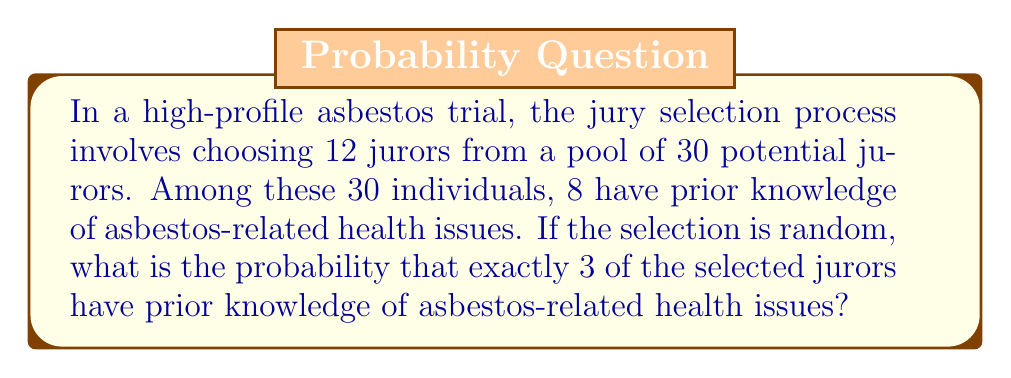Show me your answer to this math problem. Let's approach this step-by-step using the hypergeometric distribution:

1) We have:
   - Total population (N) = 30
   - Number of successes in population (K) = 8 (those with prior knowledge)
   - Sample size (n) = 12 (jury size)
   - Number of successes in sample (k) = 3 (we want exactly 3 with prior knowledge)

2) The probability is given by the hypergeometric distribution formula:

   $$P(X=k) = \frac{\binom{K}{k} \binom{N-K}{n-k}}{\binom{N}{n}}$$

3) Let's calculate each part:

   a) $\binom{K}{k} = \binom{8}{3} = 56$
   
   b) $\binom{N-K}{n-k} = \binom{22}{9} = 497,420$
   
   c) $\binom{N}{n} = \binom{30}{12} = 86,493,225$

4) Now, let's substitute these values into our formula:

   $$P(X=3) = \frac{56 \cdot 497,420}{86,493,225}$$

5) Simplifying:

   $$P(X=3) = \frac{27,855,520}{86,493,225} \approx 0.3220$$

Therefore, the probability of selecting exactly 3 jurors with prior knowledge of asbestos-related health issues is approximately 0.3220 or 32.20%.
Answer: $\frac{27,855,520}{86,493,225} \approx 0.3220$ 